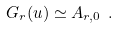Convert formula to latex. <formula><loc_0><loc_0><loc_500><loc_500>G _ { r } ( u ) \simeq A _ { r , 0 } \ .</formula> 